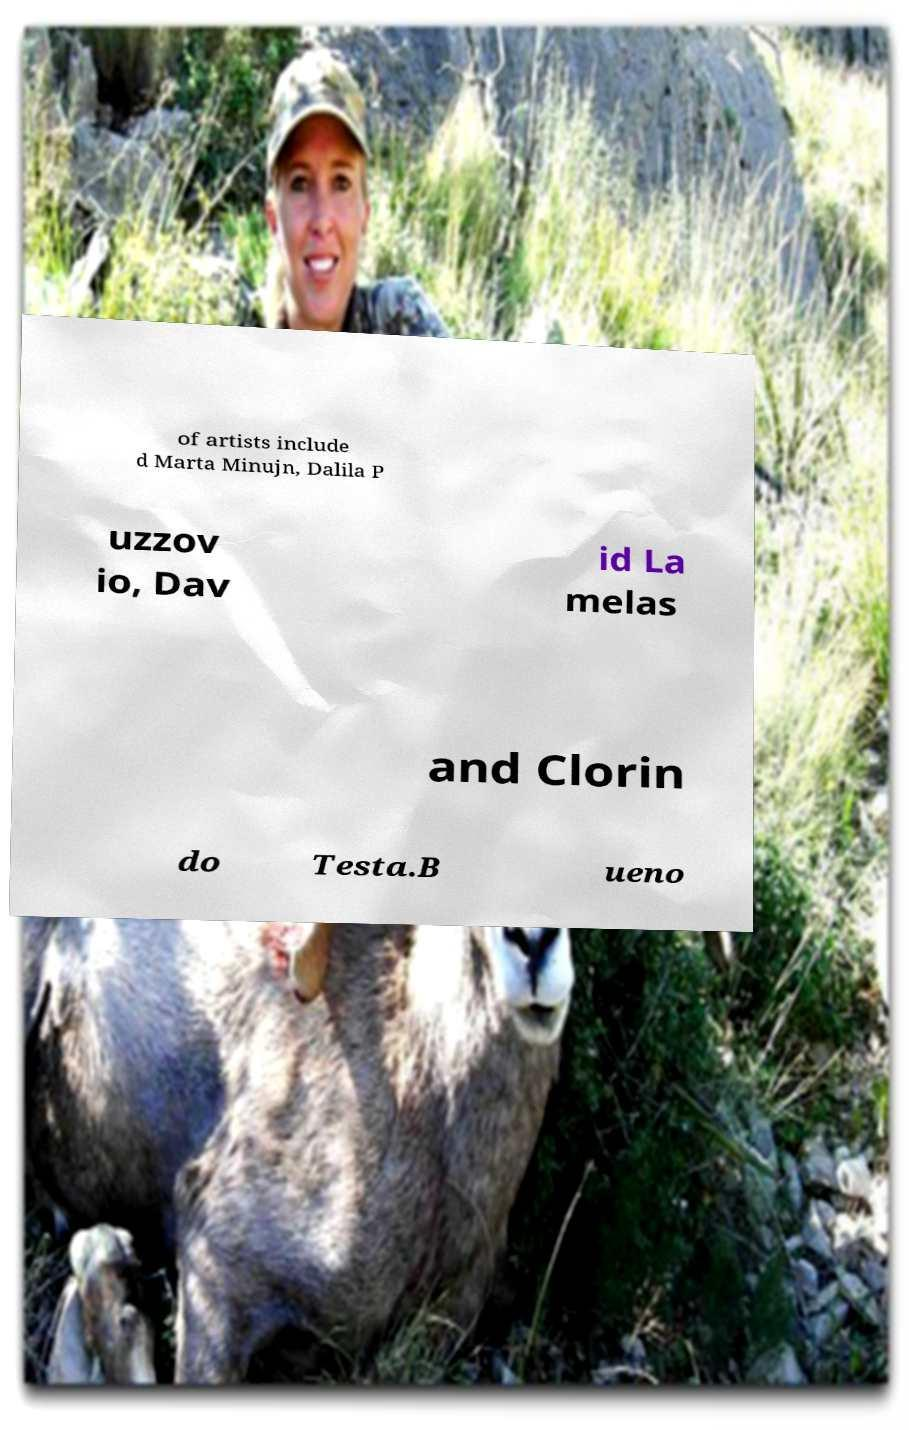Can you accurately transcribe the text from the provided image for me? of artists include d Marta Minujn, Dalila P uzzov io, Dav id La melas and Clorin do Testa.B ueno 